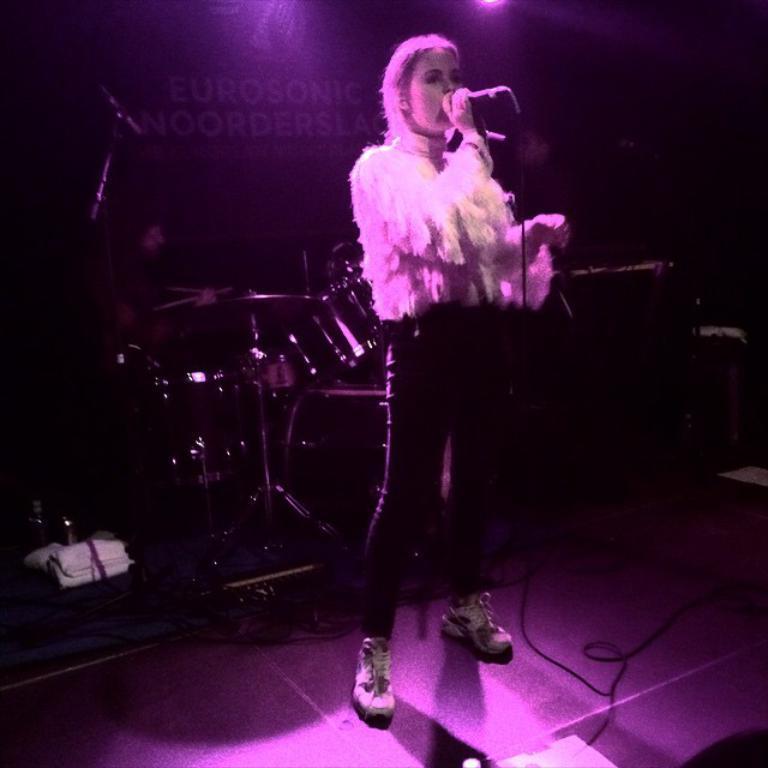How would you summarize this image in a sentence or two? A beautiful woman is standing and singing in the microphone, she wore white color top and black color trouser. Behind her there are musical instruments. 